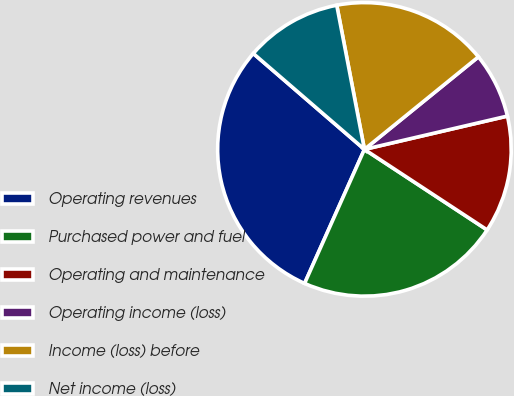<chart> <loc_0><loc_0><loc_500><loc_500><pie_chart><fcel>Operating revenues<fcel>Purchased power and fuel<fcel>Operating and maintenance<fcel>Operating income (loss)<fcel>Income (loss) before<fcel>Net income (loss)<nl><fcel>29.65%<fcel>22.44%<fcel>12.89%<fcel>7.21%<fcel>17.17%<fcel>10.65%<nl></chart> 